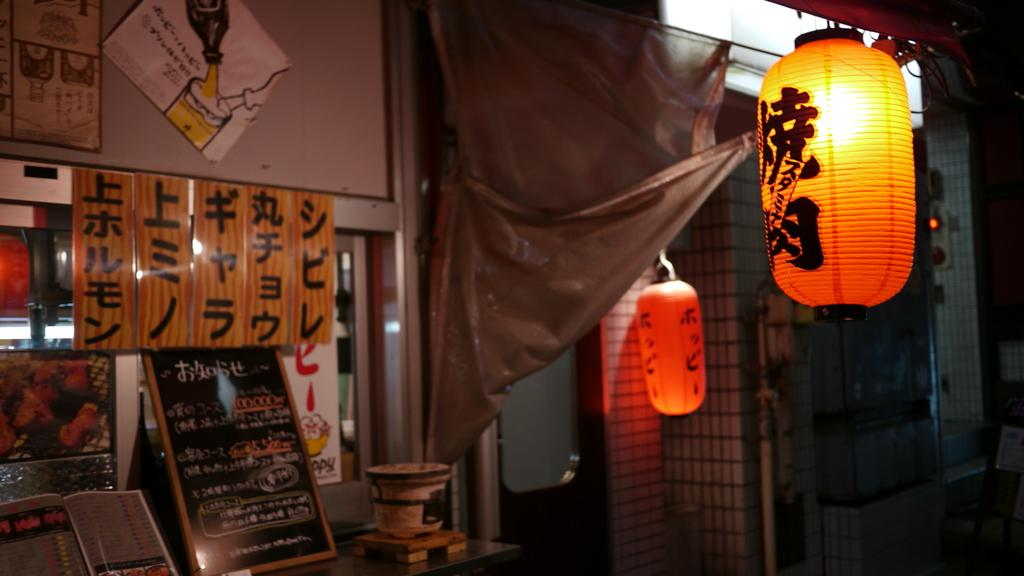What type of space is shown in the image? The image is an inside view of a room. What lighting fixtures are present in the room? There are lamps and lights in the room. What type of furniture or objects can be seen in the room? There are grills, a curtain, boards, a table, a bucket, and papers in the room. What architectural features are visible in the room? There is a wall and a roof visible at the top of the image. What type of stage can be seen in the image? There is no stage present in the image; it is an inside view of a room with various objects and features. What beliefs are represented by the objects in the image? The image does not depict any specific beliefs or ideologies; it simply shows a room with various objects and features. 